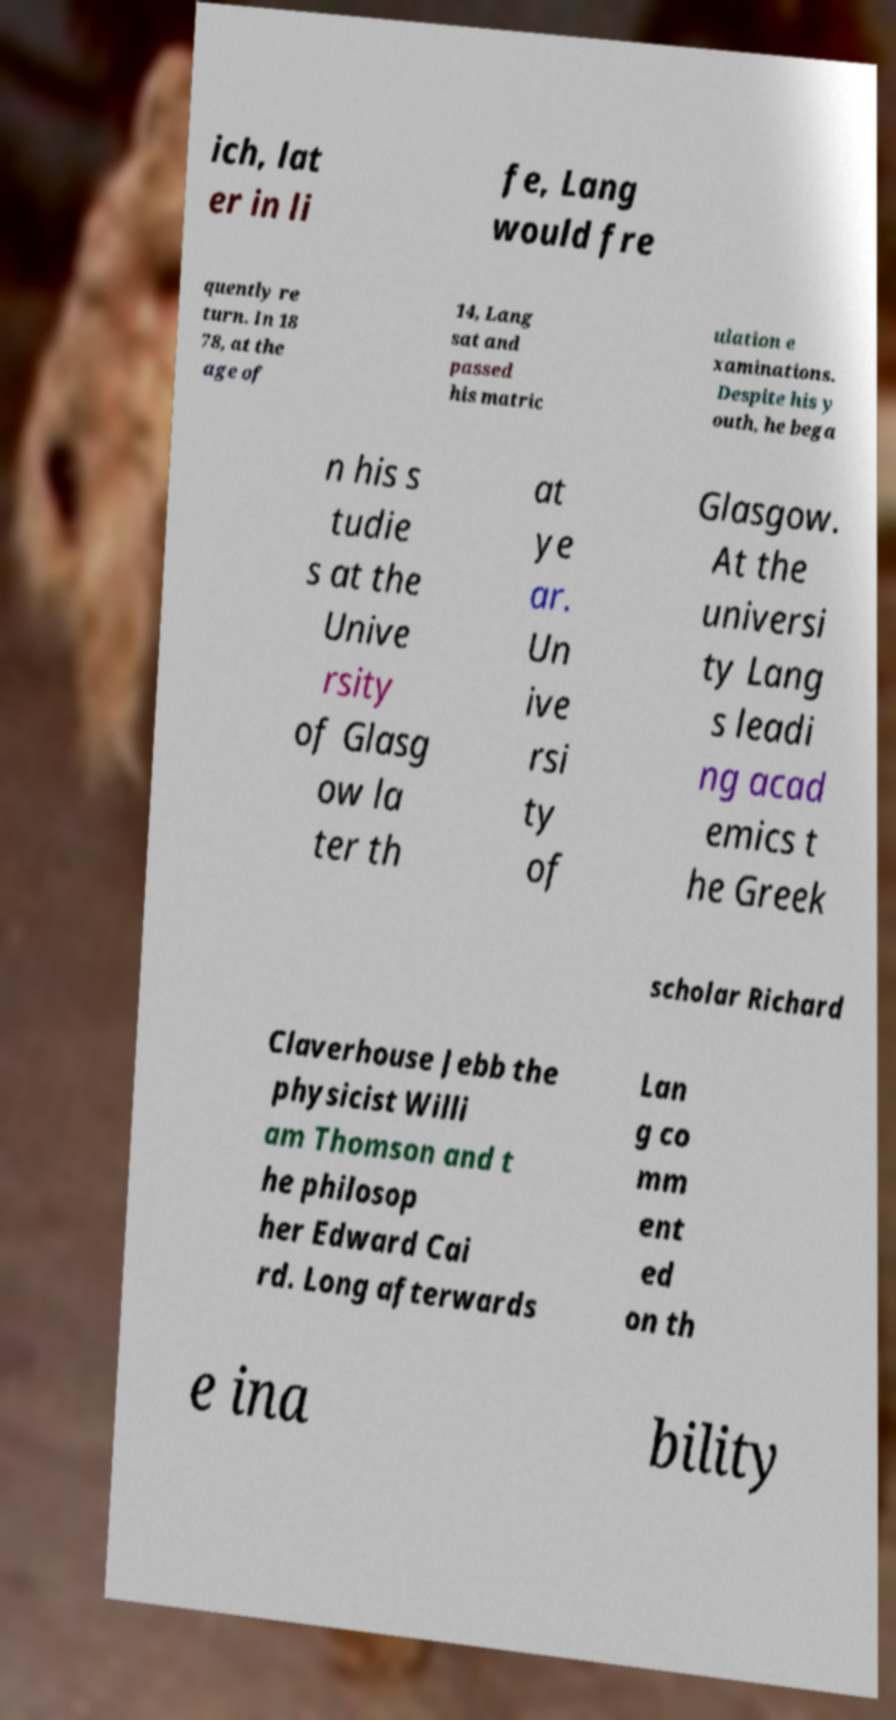Please identify and transcribe the text found in this image. ich, lat er in li fe, Lang would fre quently re turn. In 18 78, at the age of 14, Lang sat and passed his matric ulation e xaminations. Despite his y outh, he bega n his s tudie s at the Unive rsity of Glasg ow la ter th at ye ar. Un ive rsi ty of Glasgow. At the universi ty Lang s leadi ng acad emics t he Greek scholar Richard Claverhouse Jebb the physicist Willi am Thomson and t he philosop her Edward Cai rd. Long afterwards Lan g co mm ent ed on th e ina bility 